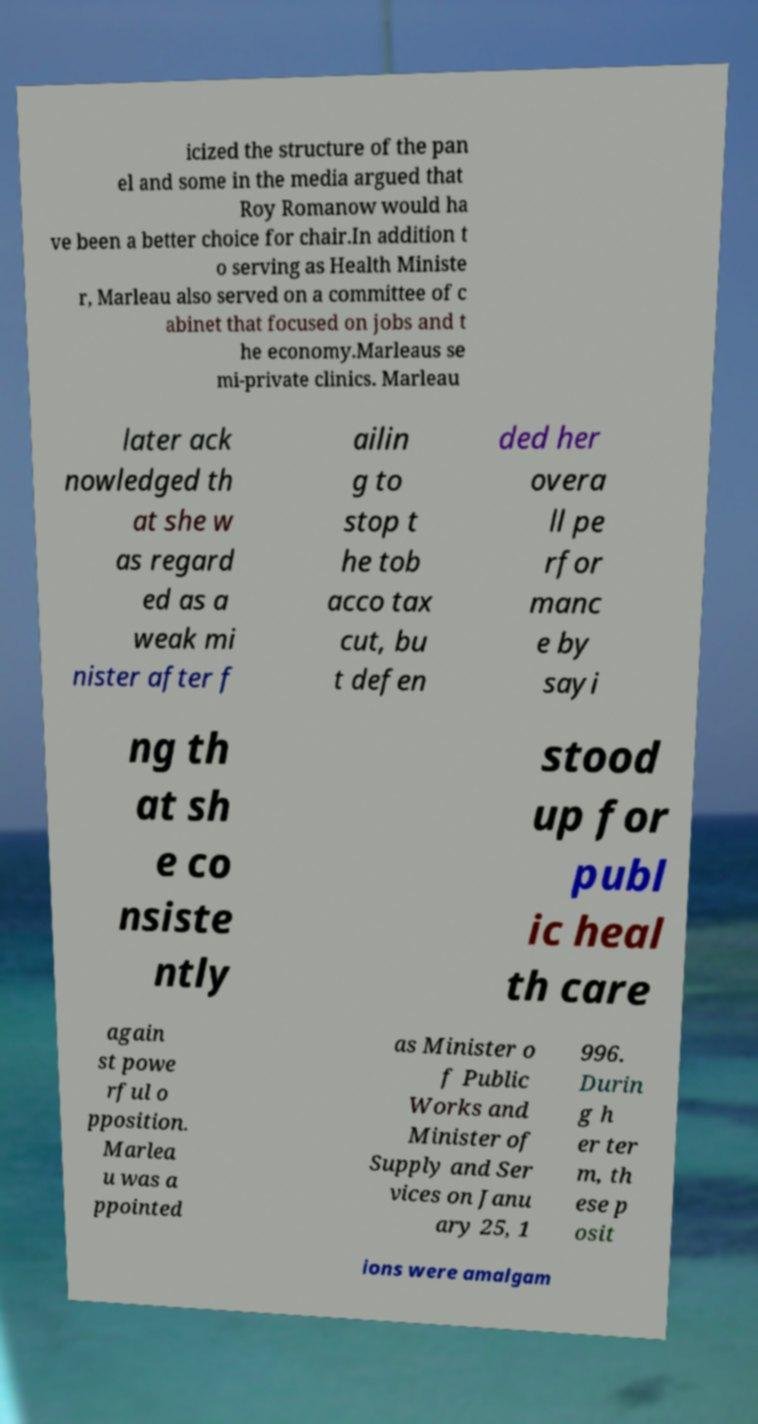I need the written content from this picture converted into text. Can you do that? icized the structure of the pan el and some in the media argued that Roy Romanow would ha ve been a better choice for chair.In addition t o serving as Health Ministe r, Marleau also served on a committee of c abinet that focused on jobs and t he economy.Marleaus se mi-private clinics. Marleau later ack nowledged th at she w as regard ed as a weak mi nister after f ailin g to stop t he tob acco tax cut, bu t defen ded her overa ll pe rfor manc e by sayi ng th at sh e co nsiste ntly stood up for publ ic heal th care again st powe rful o pposition. Marlea u was a ppointed as Minister o f Public Works and Minister of Supply and Ser vices on Janu ary 25, 1 996. Durin g h er ter m, th ese p osit ions were amalgam 